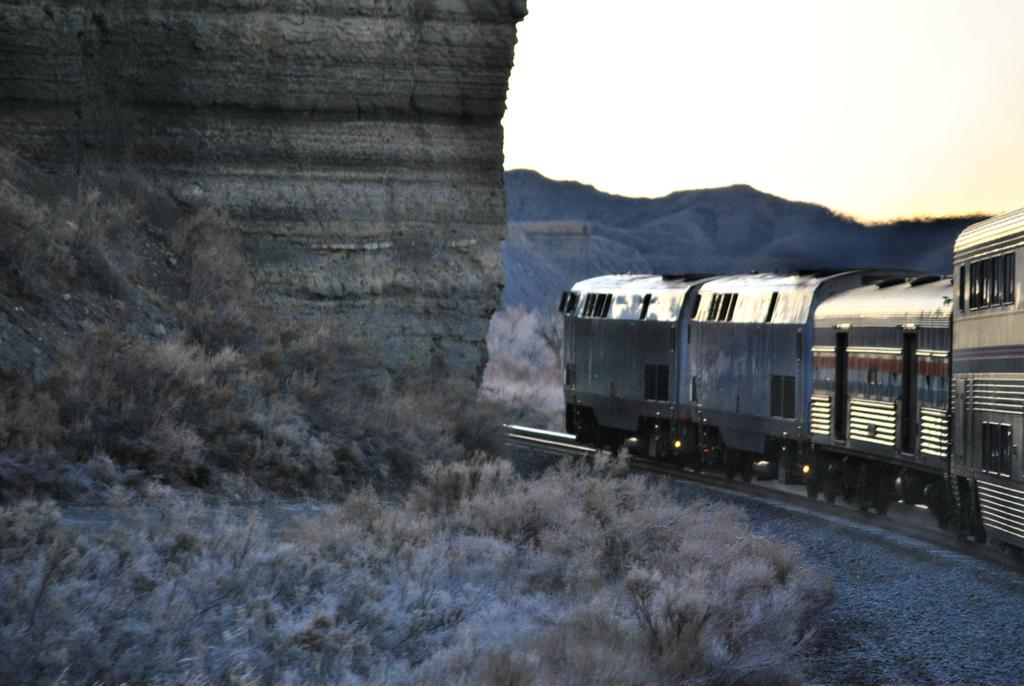What is the main subject of the image? There is a train in the image. Where is the train located? The train is on a railway track. What can be seen in the background of the image? There are mountains in the background of the image. What type of vegetation is visible at the bottom of the image? Grass is visible at the bottom of the image. What part of the sky is visible in the image? The sky is visible at the top right of the image. What type of tool is the carpenter using to fix the train in the image? There is no carpenter or tool visible in the image; it features a train on a railway track with mountains, grass, and sky in the background. How many crows are sitting on the train in the image? There are no crows present in the image; it only features a train on a railway track. 